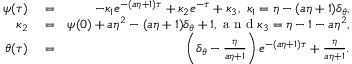<formula> <loc_0><loc_0><loc_500><loc_500>\begin{array} { r l r } { \psi ( \tau ) } & = } & { - \kappa _ { 1 } e ^ { - ( a \eta + 1 ) \tau } + \kappa _ { 2 } e ^ { - \tau } + \kappa _ { 3 } , \ \kappa _ { 1 } = \eta - ( a \eta + 1 ) \delta _ { \theta } , } \\ { \kappa _ { 2 } } & = } & { \psi ( { 0 } ) + a \eta ^ { 2 } - ( a \eta + 1 ) \delta _ { \theta } + 1 , a n d \kappa _ { 3 } = \eta - 1 - a \eta ^ { 2 } , } \\ { \theta ( \tau ) } & = } & { \left ( \delta _ { \theta } - \frac { \eta } { a \eta + 1 } \right ) e ^ { - ( a \eta + 1 ) \tau } + \frac { \eta } { a \eta + 1 } . } \end{array}</formula> 